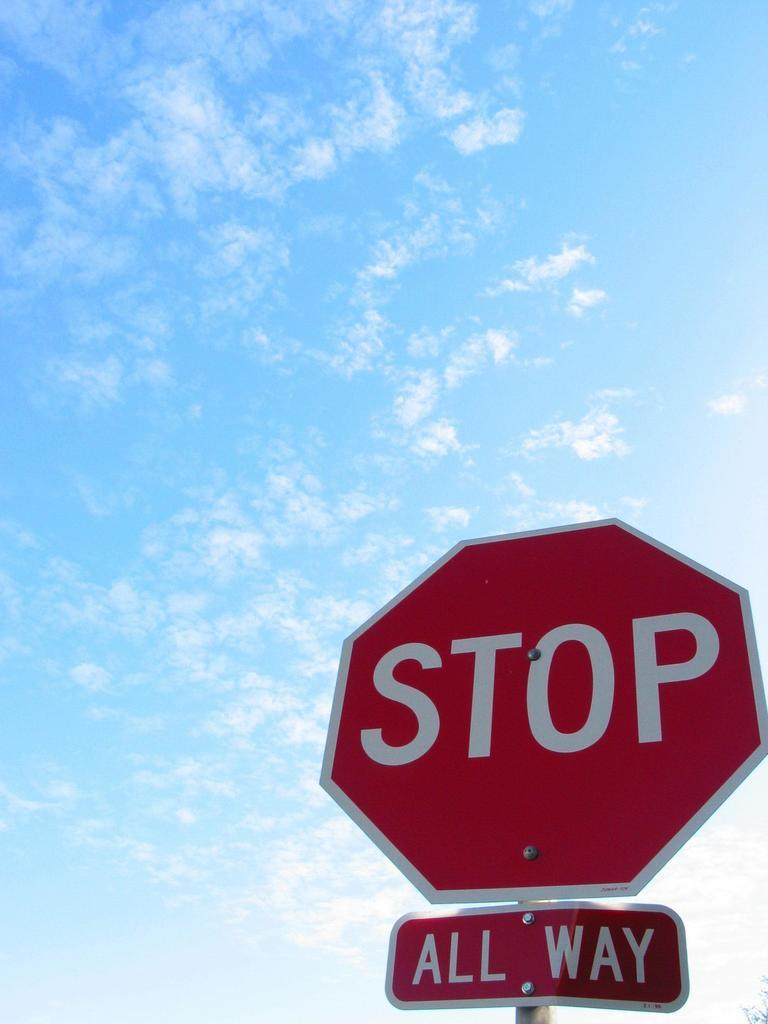<image>
Render a clear and concise summary of the photo. A red stop sign that says Stop on it in white letters. 